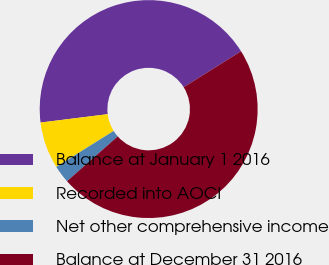<chart> <loc_0><loc_0><loc_500><loc_500><pie_chart><fcel>Balance at January 1 2016<fcel>Recorded into AOCI<fcel>Net other comprehensive income<fcel>Balance at December 31 2016<nl><fcel>43.08%<fcel>6.92%<fcel>2.62%<fcel>47.38%<nl></chart> 